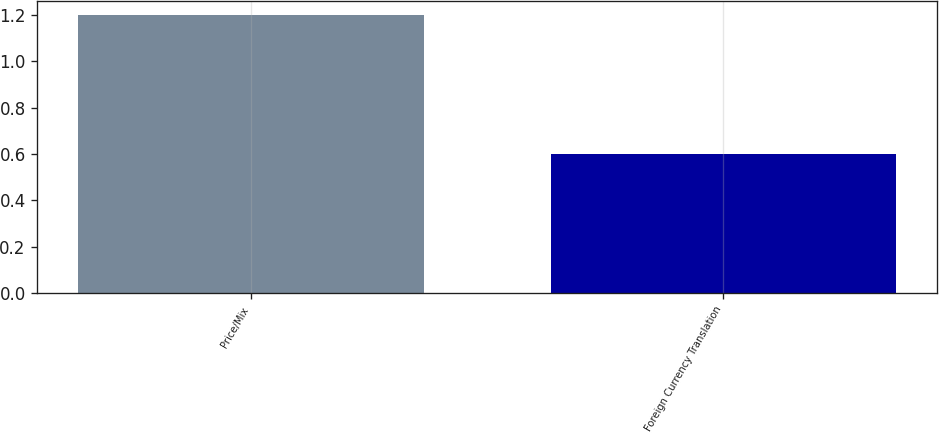<chart> <loc_0><loc_0><loc_500><loc_500><bar_chart><fcel>Price/Mix<fcel>Foreign Currency Translation<nl><fcel>1.2<fcel>0.6<nl></chart> 